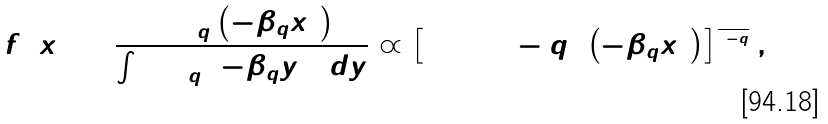<formula> <loc_0><loc_0><loc_500><loc_500>f \left ( x \right ) = \frac { \exp _ { q } \left ( - \beta _ { q } x ^ { 2 } \right ) } { \int \exp _ { q } \left ( - \beta _ { q } y ^ { 2 } \right ) d y } \varpropto \left [ 1 + \left ( 1 - q \right ) \left ( - \beta _ { q } x ^ { 2 } \right ) \right ] ^ { \frac { 1 } { 1 - q } } ,</formula> 